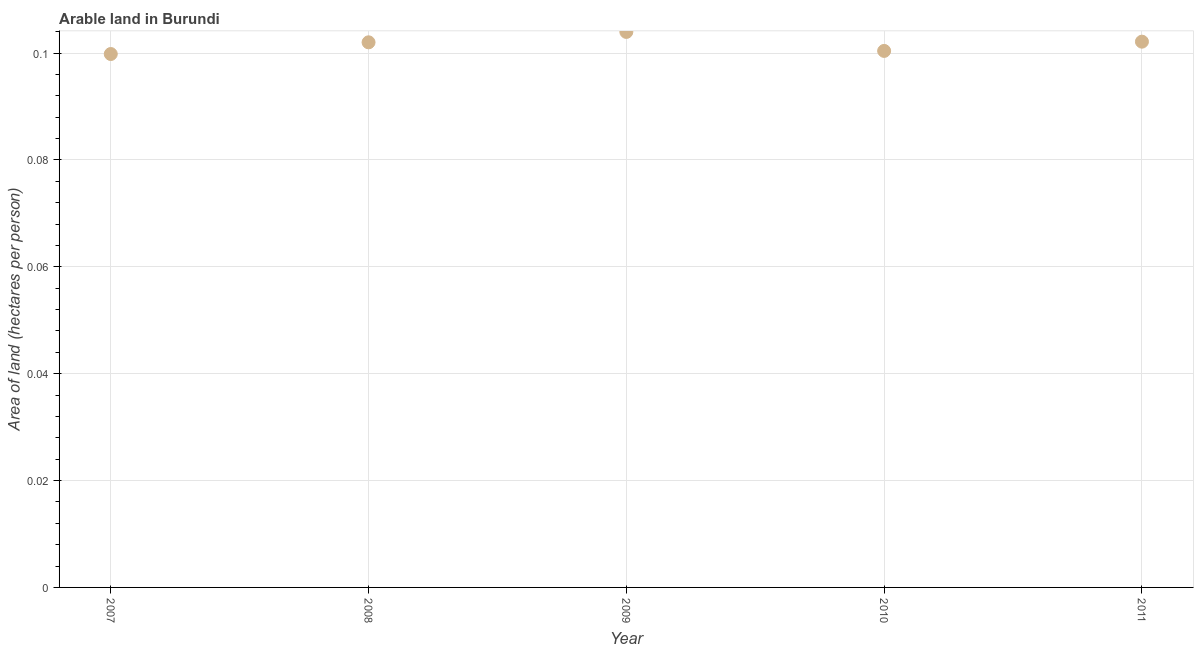What is the area of arable land in 2010?
Provide a short and direct response. 0.1. Across all years, what is the maximum area of arable land?
Offer a terse response. 0.1. Across all years, what is the minimum area of arable land?
Offer a very short reply. 0.1. In which year was the area of arable land maximum?
Offer a very short reply. 2009. What is the sum of the area of arable land?
Keep it short and to the point. 0.51. What is the difference between the area of arable land in 2009 and 2010?
Provide a succinct answer. 0. What is the average area of arable land per year?
Offer a terse response. 0.1. What is the median area of arable land?
Your answer should be compact. 0.1. Do a majority of the years between 2010 and 2008 (inclusive) have area of arable land greater than 0.072 hectares per person?
Offer a terse response. No. What is the ratio of the area of arable land in 2008 to that in 2011?
Provide a succinct answer. 1. Is the area of arable land in 2007 less than that in 2011?
Your response must be concise. Yes. Is the difference between the area of arable land in 2010 and 2011 greater than the difference between any two years?
Your answer should be very brief. No. What is the difference between the highest and the second highest area of arable land?
Your answer should be compact. 0. Is the sum of the area of arable land in 2008 and 2011 greater than the maximum area of arable land across all years?
Offer a very short reply. Yes. What is the difference between the highest and the lowest area of arable land?
Provide a succinct answer. 0. In how many years, is the area of arable land greater than the average area of arable land taken over all years?
Offer a very short reply. 3. Does the area of arable land monotonically increase over the years?
Provide a succinct answer. No. Are the values on the major ticks of Y-axis written in scientific E-notation?
Your response must be concise. No. What is the title of the graph?
Your response must be concise. Arable land in Burundi. What is the label or title of the Y-axis?
Provide a succinct answer. Area of land (hectares per person). What is the Area of land (hectares per person) in 2007?
Offer a very short reply. 0.1. What is the Area of land (hectares per person) in 2008?
Your answer should be compact. 0.1. What is the Area of land (hectares per person) in 2009?
Your answer should be very brief. 0.1. What is the Area of land (hectares per person) in 2010?
Keep it short and to the point. 0.1. What is the Area of land (hectares per person) in 2011?
Provide a succinct answer. 0.1. What is the difference between the Area of land (hectares per person) in 2007 and 2008?
Your response must be concise. -0. What is the difference between the Area of land (hectares per person) in 2007 and 2009?
Keep it short and to the point. -0. What is the difference between the Area of land (hectares per person) in 2007 and 2010?
Ensure brevity in your answer.  -0. What is the difference between the Area of land (hectares per person) in 2007 and 2011?
Your response must be concise. -0. What is the difference between the Area of land (hectares per person) in 2008 and 2009?
Give a very brief answer. -0. What is the difference between the Area of land (hectares per person) in 2008 and 2010?
Make the answer very short. 0. What is the difference between the Area of land (hectares per person) in 2008 and 2011?
Provide a succinct answer. -0. What is the difference between the Area of land (hectares per person) in 2009 and 2010?
Your answer should be very brief. 0. What is the difference between the Area of land (hectares per person) in 2009 and 2011?
Offer a terse response. 0. What is the difference between the Area of land (hectares per person) in 2010 and 2011?
Offer a very short reply. -0. What is the ratio of the Area of land (hectares per person) in 2007 to that in 2010?
Ensure brevity in your answer.  0.99. What is the ratio of the Area of land (hectares per person) in 2007 to that in 2011?
Offer a terse response. 0.98. What is the ratio of the Area of land (hectares per person) in 2009 to that in 2010?
Your response must be concise. 1.03. What is the ratio of the Area of land (hectares per person) in 2010 to that in 2011?
Make the answer very short. 0.98. 